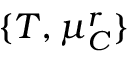<formula> <loc_0><loc_0><loc_500><loc_500>\{ T , \mu _ { C } ^ { r } \}</formula> 